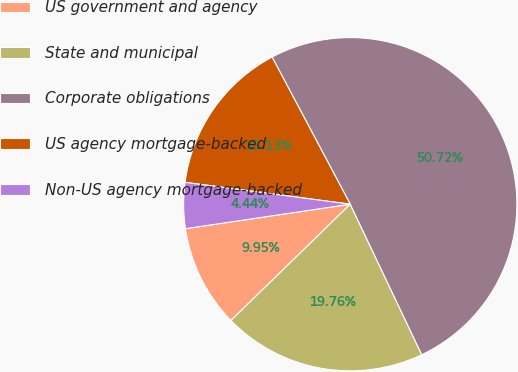Convert chart to OTSL. <chart><loc_0><loc_0><loc_500><loc_500><pie_chart><fcel>US government and agency<fcel>State and municipal<fcel>Corporate obligations<fcel>US agency mortgage-backed<fcel>Non-US agency mortgage-backed<nl><fcel>9.95%<fcel>19.76%<fcel>50.71%<fcel>15.13%<fcel>4.44%<nl></chart> 